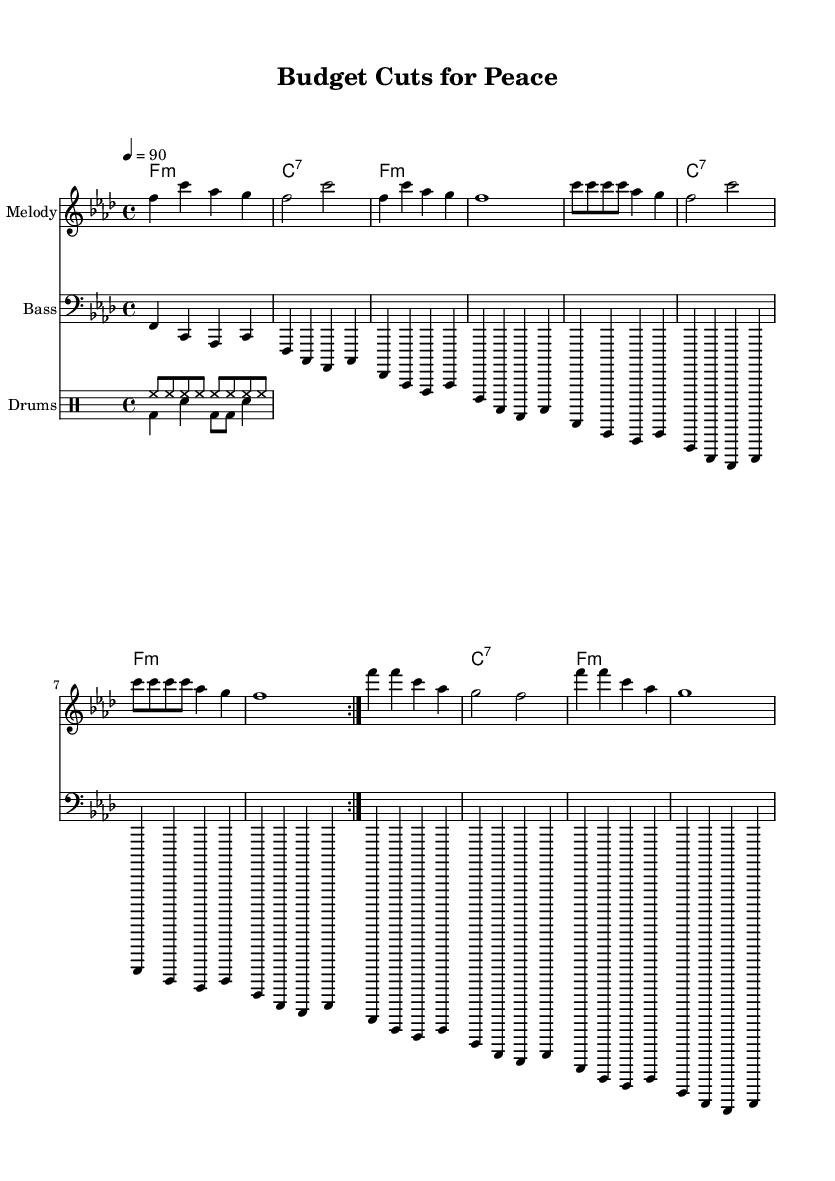What is the key signature of this music? The key signature is F minor, which has four flats. This is indicated at the beginning of the score where the key signature is shown.
Answer: F minor What is the time signature of this music? The time signature is 4/4, meaning there are four beats in each measure and the quarter note gets one beat. This can be seen at the beginning of the score.
Answer: 4/4 What is the tempo marking of this music? The tempo marking is quarter note equals 90 BPM. This indicates that there should be 90 beats per minute, which is shown at the beginning of the score.
Answer: 90 How many volta repeats are in the melody section? The melody section has 2 volta repeats, as indicated by the repeat sign and the "volta" instruction in the score. This means that the musician will play the section twice before moving on.
Answer: 2 What is the chord progression used in this piece? The chord progression used consists of F minor and C7 chords that repeat through the music, as indicated in the chord names section. The pattern is consistent throughout the piece, suggesting a strong emphasis on these harmonies.
Answer: F minor, C7 What instruments are featured in this score? The score features a Melody staff, a Bass staff, and a Drum staff, which are explicitly labeled at the beginning of each staff in the score. This indicates that the arrangement is meant for these three instrumental components typical in Hip Hop music.
Answer: Melody, Bass, Drums What thematic content does the title suggest regarding social issues? The title "Budget Cuts for Peace" implies a focus on social inequality and the critique of government spending, aligning with the conscious hip-hop genre's objective to address societal problems. This thematic connection can be deduced from the title's specific language.
Answer: Social inequality, government spending 